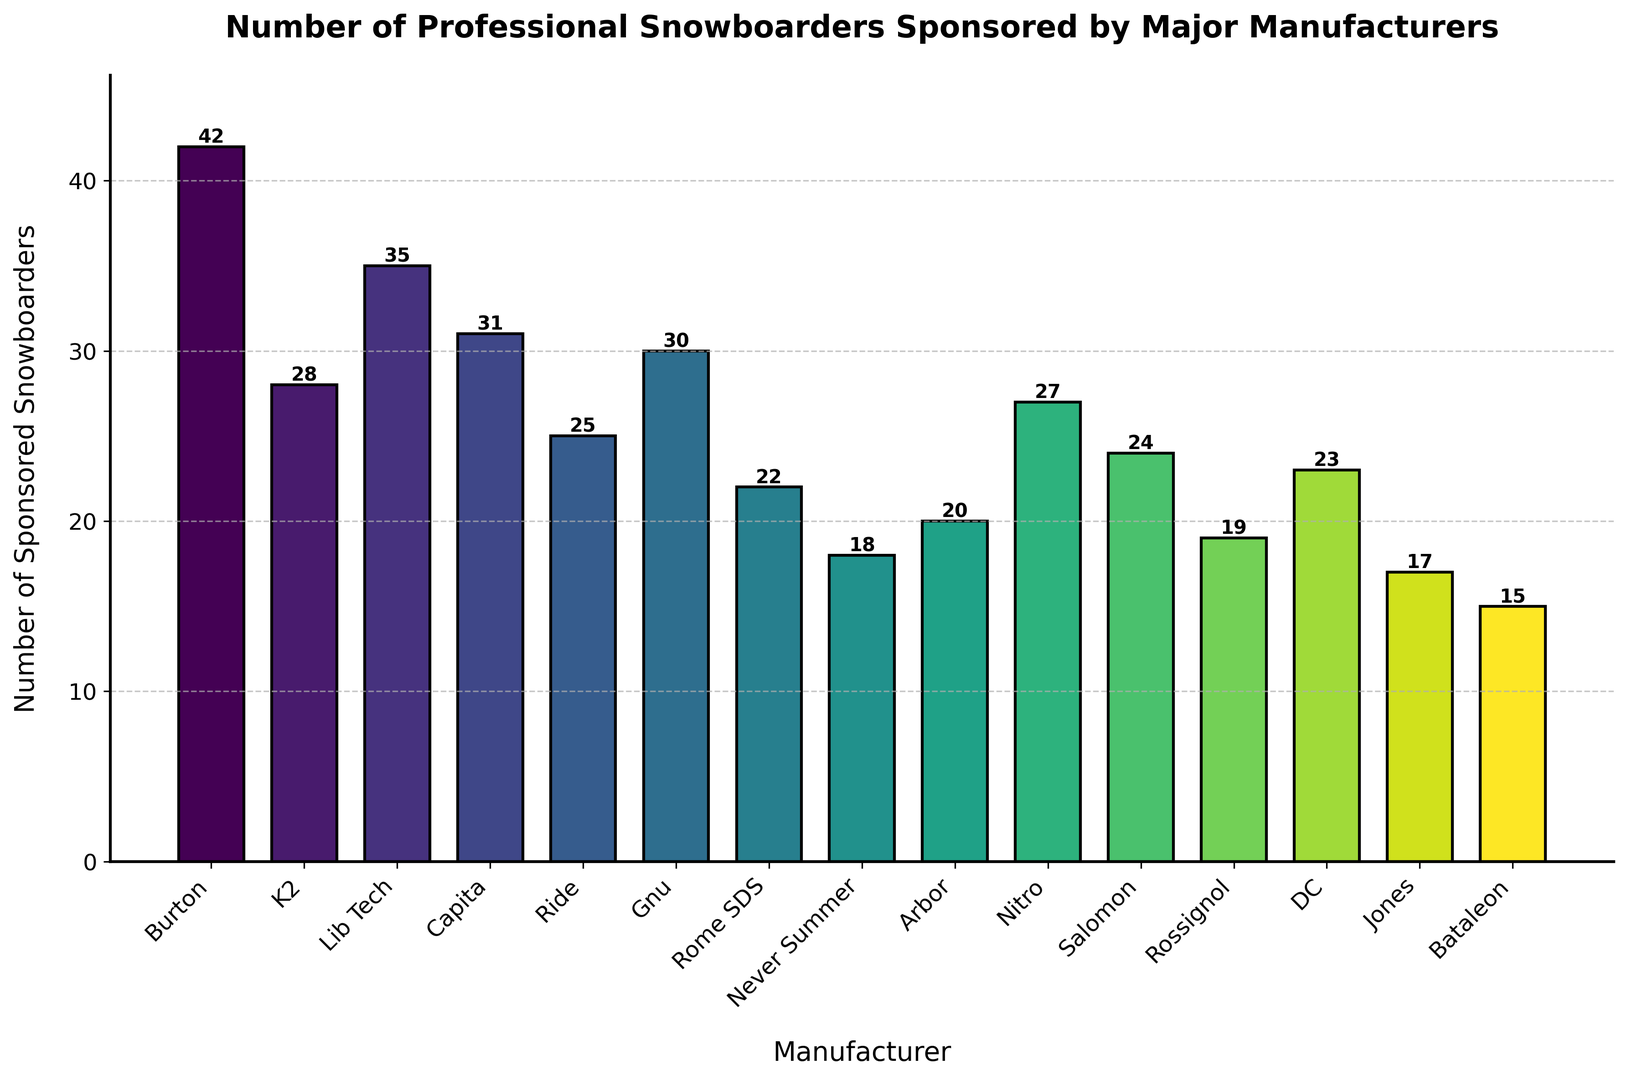Which manufacturer sponsors the highest number of professional snowboarders? First, we look at the heights of the bars and find the tallest one, which corresponds to Burton with 42 snowboarders.
Answer: Burton Which manufacturer sponsors fewer professional snowboarders, Capita or Nitro? Observe the heights of the bars representing Capita and Nitro. Capita sponsors 31 snowboarders while Nitro sponsors 27. Nitro sponsors fewer snowboarders.
Answer: Nitro What is the combined total of snowboarders sponsored by Ride and Gnu? Locate the bars for Ride and Gnu. Ride sponsors 25 snowboarders and Gnu sponsors 30 snowboarders. Adding these together, 25 + 30 = 55.
Answer: 55 What's the average number of snowboarders sponsored by Burton, Lib Tech, and Arbor? Add the number of snowboarders from Burton (42), Lib Tech (35), and Arbor (20), which gives 97. Divide it by the number of manufacturers (3). The average is 97/3 = 32.33.
Answer: 32.33 Which manufacturers sponsor more snowboarders than Nitro? Identify the number of snowboarders sponsored by Nitro, which is 27. Then compare it with other manufacturers: Burton (42), Lib Tech (35), Capita (31), Gnu (30), and K2 (28) sponsor more snowboarders than Nitro.
Answer: Burton, Lib Tech, Capita, Gnu, K2 How many more snowboarders does Burton sponsor compared to Rossignol? Burton sponsors 42 snowboarders, and Rossignol sponsors 19. Calculate the difference: 42 - 19 = 23.
Answer: 23 Are there any manufacturers sponsoring exactly 20 snowboarders? Look through the bars for the manufacturer that sponsors 20 snowboarders, which is Arbor.
Answer: Arbor What is the range of snowboarders sponsored by all manufacturers? Find the difference between the highest number (Burton with 42) and the lowest number (Bataleon with 15). The range is 42 - 15 = 27.
Answer: 27 What fraction of the total snowboarders are sponsored by Salomon? Sum the snowboarders from all manufacturers: 42 + 28 + 35 + 31 + 25 + 30 + 22 + 18 + 20 + 27 + 24 + 19 + 23 + 17 + 15 = 376. Salomon sponsors 24 snowboarders. The fraction is 24/376 = 0.0638.
Answer: 0.0638 (approx) How does the number of snowboarders sponsored by Never Summer compare to Rome SDS? Never Summer sponsors 18 snowboarders whereas Rome SDS sponsors 22. Rome SDS sponsors more snowboarders than Never Summer.
Answer: Rome SDS 